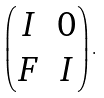<formula> <loc_0><loc_0><loc_500><loc_500>\left ( \begin{matrix} I & 0 \\ F & I \end{matrix} \right ) .</formula> 